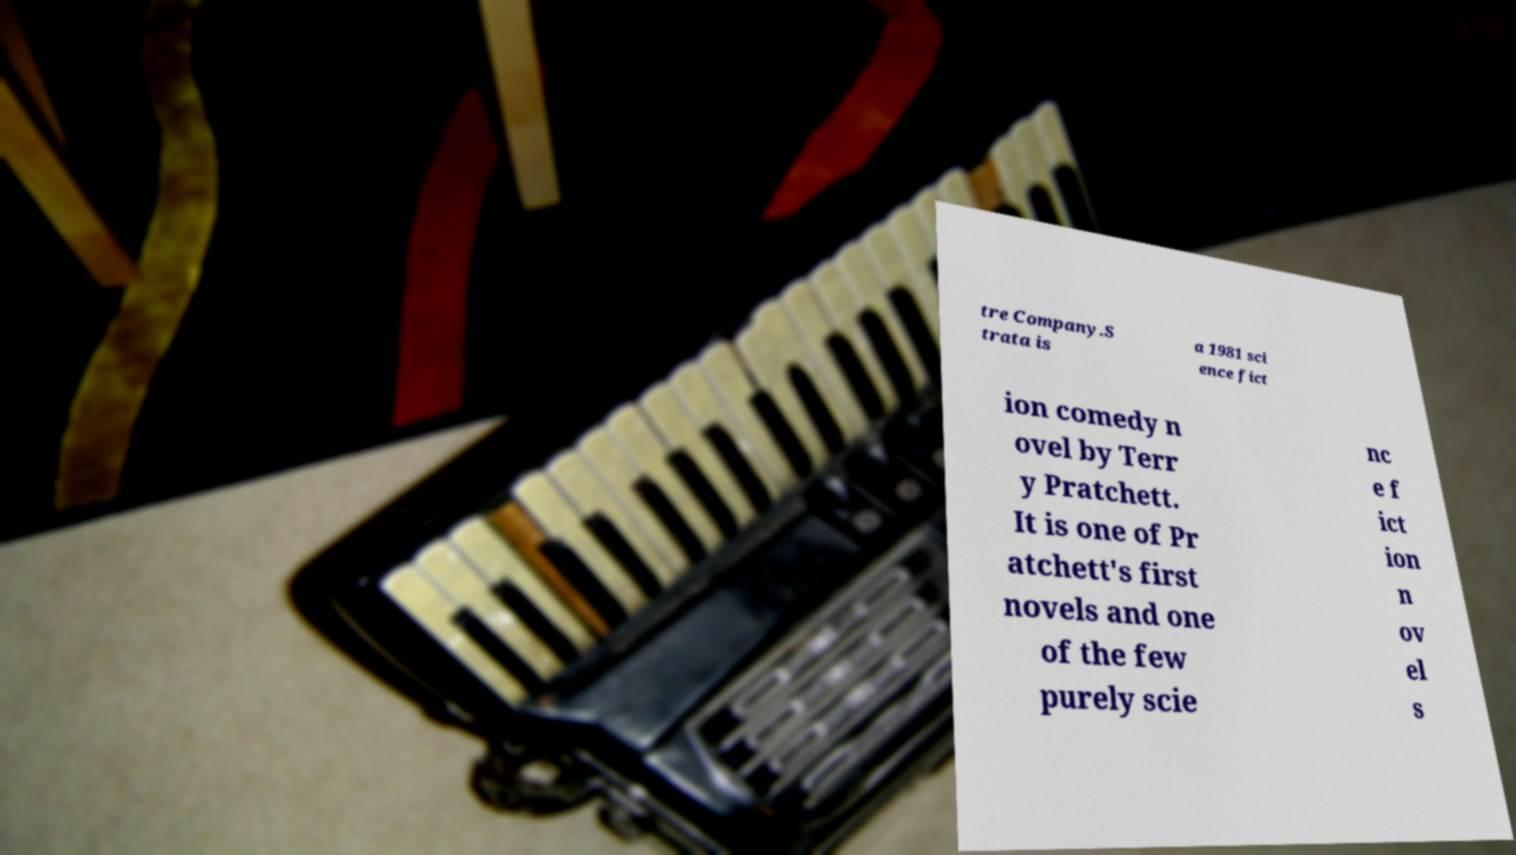For documentation purposes, I need the text within this image transcribed. Could you provide that? tre Company.S trata is a 1981 sci ence fict ion comedy n ovel by Terr y Pratchett. It is one of Pr atchett's first novels and one of the few purely scie nc e f ict ion n ov el s 